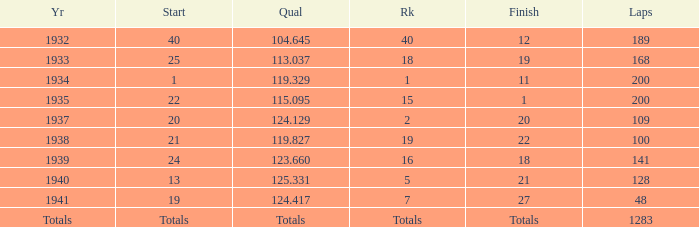What was the finish place with a qual of 123.660? 18.0. 